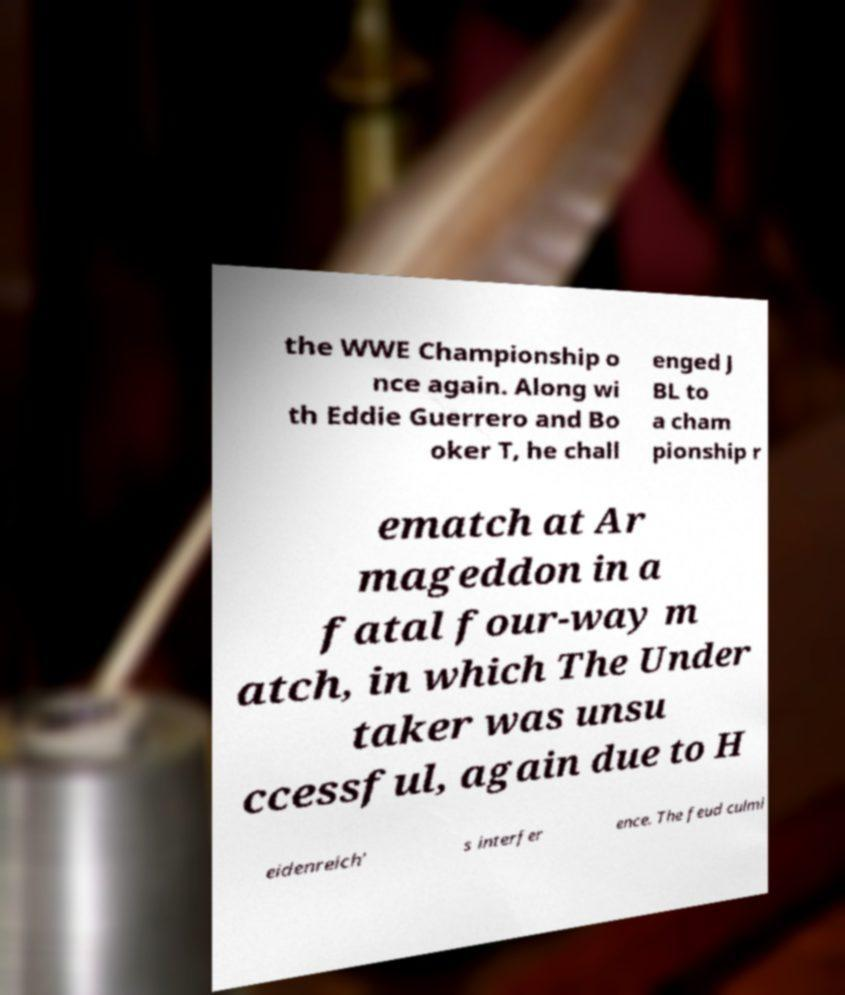Could you extract and type out the text from this image? the WWE Championship o nce again. Along wi th Eddie Guerrero and Bo oker T, he chall enged J BL to a cham pionship r ematch at Ar mageddon in a fatal four-way m atch, in which The Under taker was unsu ccessful, again due to H eidenreich' s interfer ence. The feud culmi 